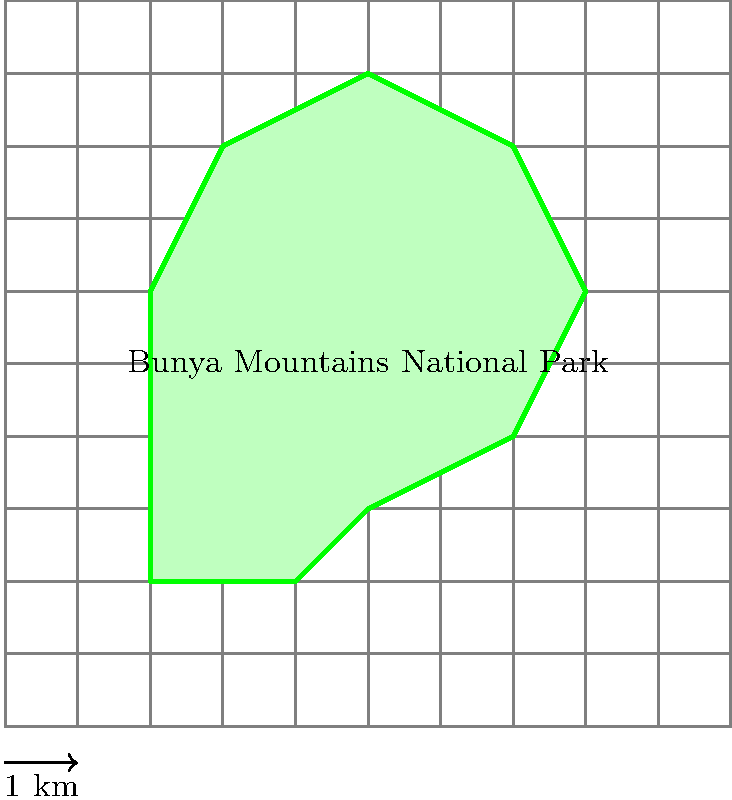As a local tourist guide in the Bunya Mountains, you're often asked about the size of the national park. Using the grid overlay where each square represents 1 square kilometer, estimate the area of the Bunya Mountains National Park shown in the image. Round your answer to the nearest whole number. To estimate the area of the irregular-shaped Bunya Mountains National Park using the grid overlay, we can follow these steps:

1. Count the number of full squares within the park boundaries:
   There are approximately 13 full squares.

2. Count the number of partial squares that are more than half filled:
   There are about 11 squares that are more than half filled.

3. Count the number of partial squares that are less than half filled:
   There are about 6 squares that are less than half filled.

4. Calculate the estimated area:
   - Full squares: 13
   - More than half filled (count as 1 each): 11
   - Less than half filled (count as 0.5 each): 6 × 0.5 = 3

   Total estimated area = 13 + 11 + 3 = 27 square kilometers

5. Round to the nearest whole number:
   27 square kilometers (no rounding needed in this case)

Therefore, the estimated area of the Bunya Mountains National Park based on the grid overlay is approximately 27 square kilometers.
Answer: 27 km² 